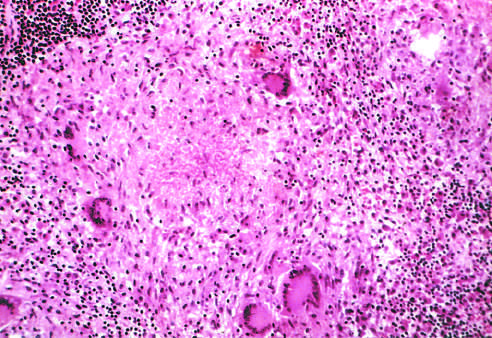what does typical tuberculous granuloma show?
Answer the question using a single word or phrase. An area of central necrosis 